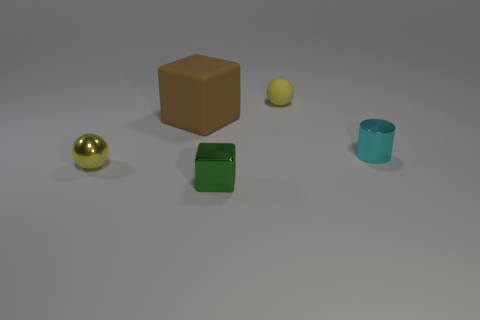What number of big brown objects have the same shape as the small green thing?
Offer a very short reply. 1. There is a tiny yellow sphere in front of the yellow matte object; how many tiny cubes are in front of it?
Offer a terse response. 1. What number of shiny objects are tiny yellow things or gray things?
Make the answer very short. 1. Is there a yellow sphere made of the same material as the big brown object?
Ensure brevity in your answer.  Yes. What number of objects are things that are right of the tiny cube or tiny balls to the left of the tiny rubber sphere?
Keep it short and to the point. 3. There is a shiny thing that is behind the yellow metallic sphere; is its color the same as the large thing?
Your response must be concise. No. What number of other objects are there of the same color as the rubber sphere?
Your answer should be very brief. 1. What material is the big brown thing?
Offer a very short reply. Rubber. There is a thing right of the yellow matte object; is it the same size as the small matte thing?
Provide a short and direct response. Yes. Is there anything else that has the same size as the rubber cube?
Give a very brief answer. No. 